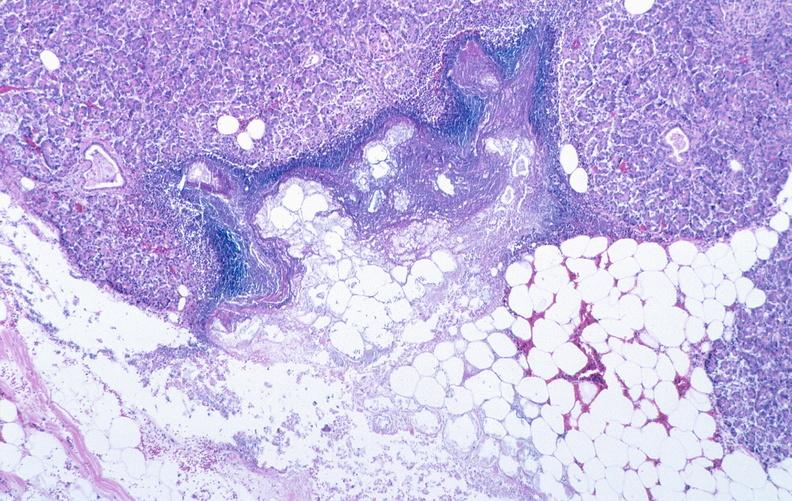what does this image show?
Answer the question using a single word or phrase. Pancreatic fat necrosis 